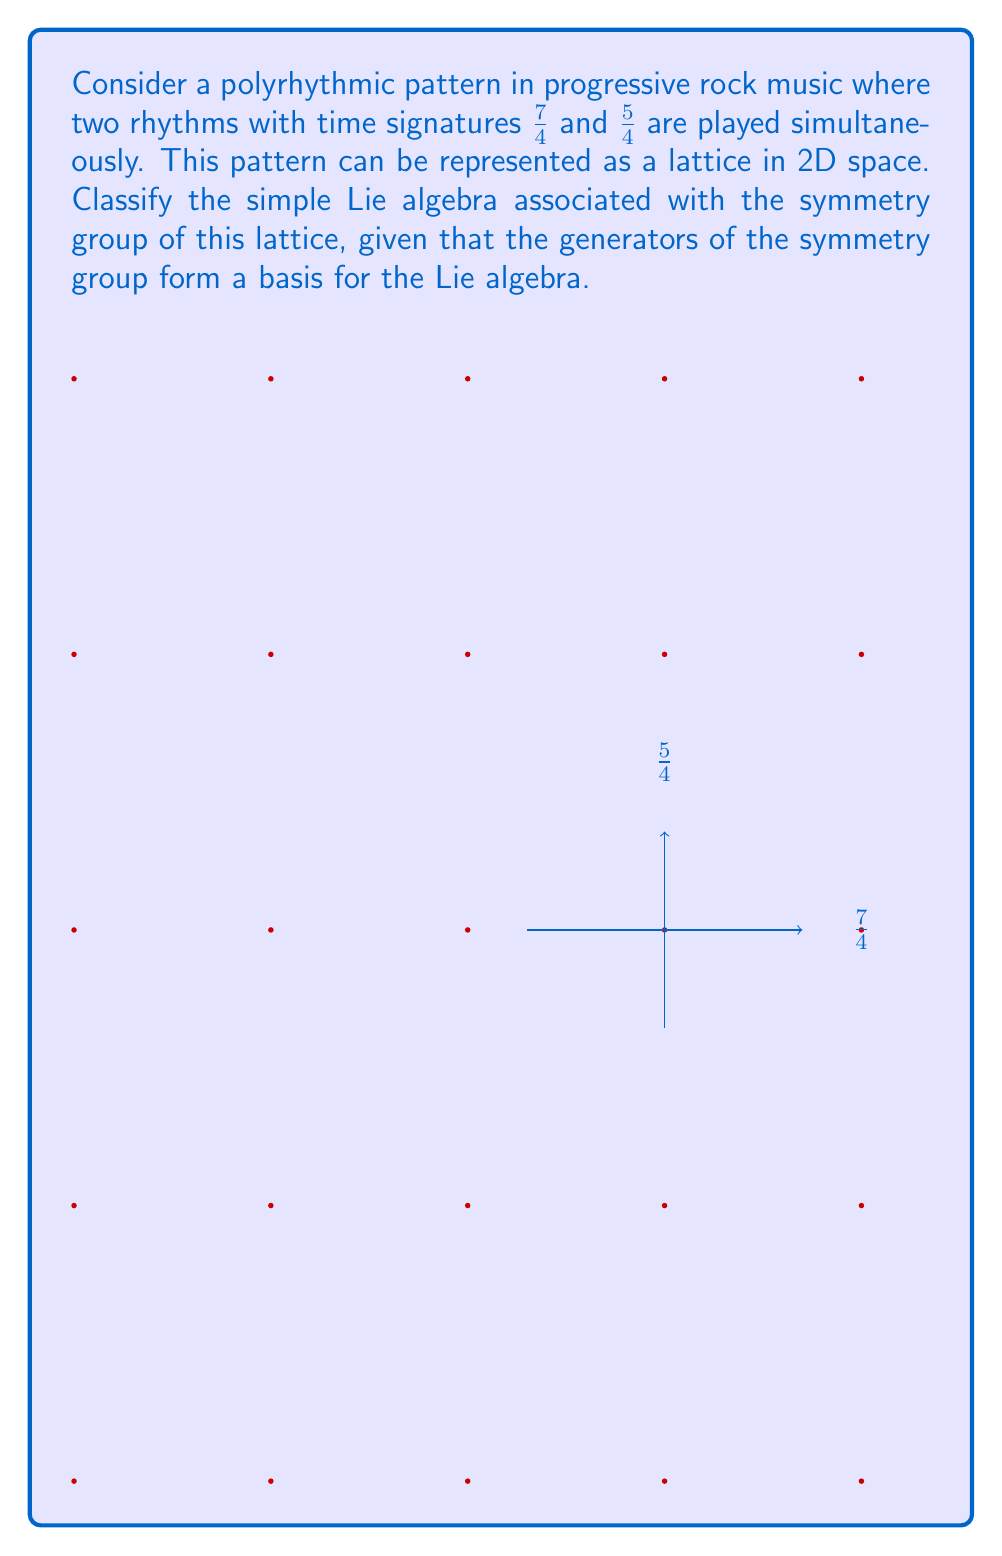Show me your answer to this math problem. To classify the simple Lie algebra associated with the symmetry group of this lattice, we follow these steps:

1) First, we identify the symmetry group of the lattice. The lattice is periodic in two dimensions, with periods 5 and 7 in the x and y directions, respectively. This forms a 2D rectangular lattice.

2) The symmetry group of a 2D rectangular lattice is isomorphic to the orthogonal group $O(2)$, which includes rotations and reflections in 2D space.

3) The Lie algebra associated with $O(2)$ is $\mathfrak{so}(2)$, the special orthogonal algebra in 2 dimensions.

4) $\mathfrak{so}(2)$ is a 1-dimensional Lie algebra. Its single generator can be represented by the matrix:

   $$J = \begin{pmatrix} 0 & -1 \\ 1 & 0 \end{pmatrix}$$

5) To classify this Lie algebra in terms of the simple Lie algebras, we need to identify which of the classical series it belongs to.

6) The classical simple Lie algebras are classified into four infinite series: $A_n$, $B_n$, $C_n$, and $D_n$, plus five exceptional cases.

7) $\mathfrak{so}(2)$ is isomorphic to $\mathfrak{u}(1)$, the Lie algebra of the unitary group $U(1)$.

8) $\mathfrak{u}(1)$ is not a simple Lie algebra, as it is abelian (all elements commute). However, it is closely related to the $A_n$ series.

9) Specifically, $\mathfrak{so}(2) \cong \mathfrak{u}(1)$ can be seen as a subalgebra of $\mathfrak{su}(2)$, which is the $A_1$ simple Lie algebra.

Therefore, while $\mathfrak{so}(2)$ itself is not simple, it is most closely associated with the $A_1$ simple Lie algebra in the classification scheme.
Answer: $A_1$ 